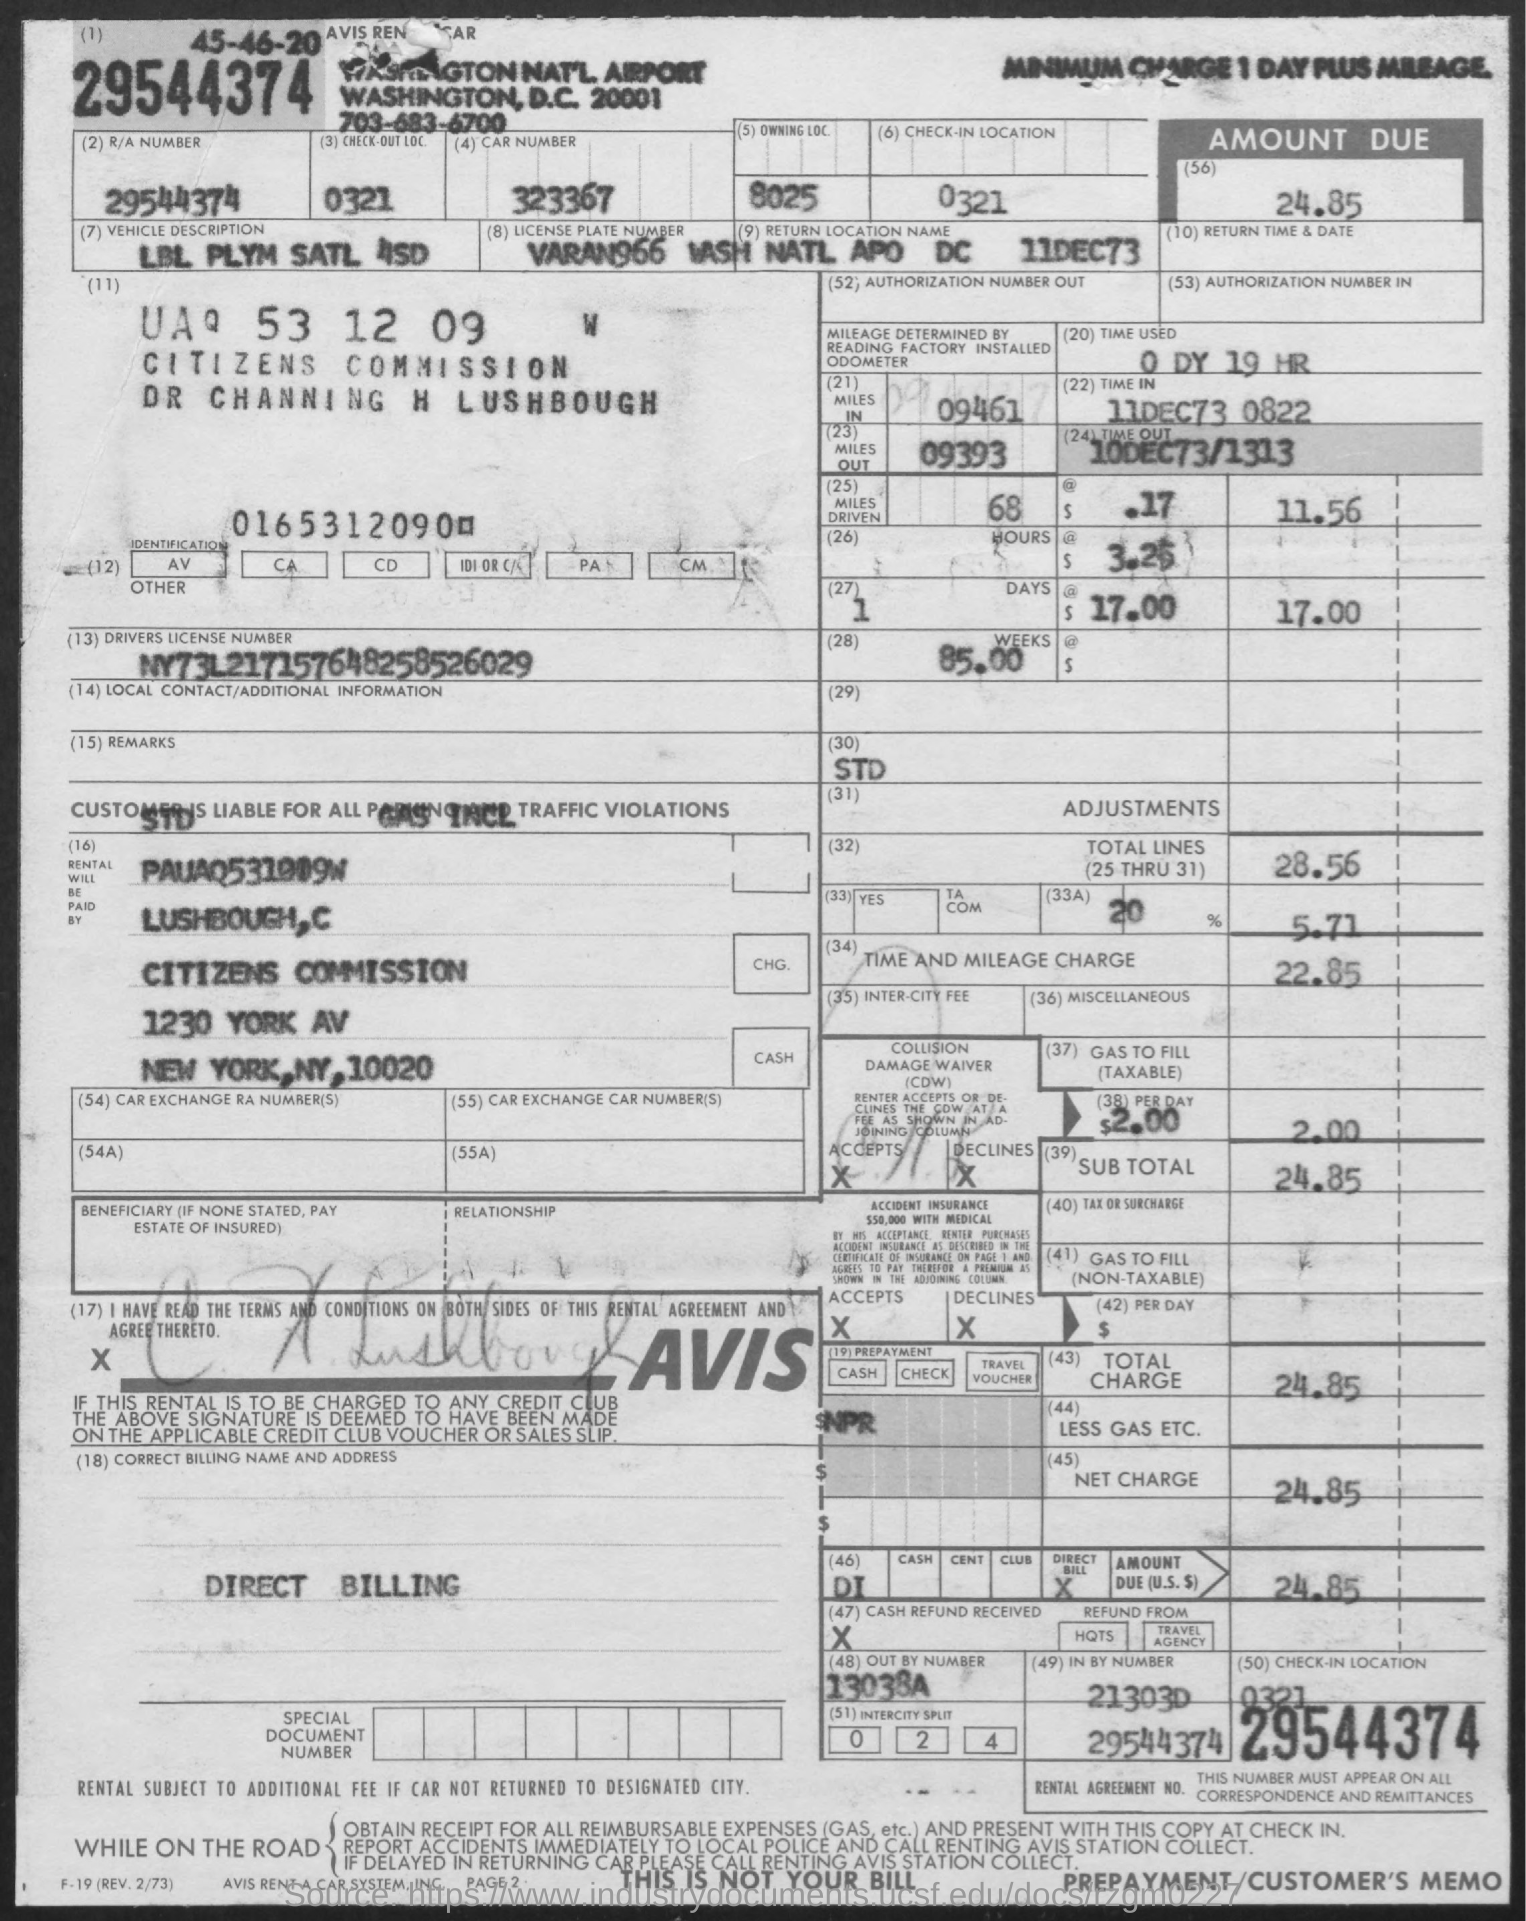What is the R/A Number of the car?
Your answer should be compact. 29544374. What is the car number given?
Your answer should be compact. 323367. What is the vehicle description mentioned in the document?
Your response must be concise. LBL PLYM SATL 4SD. What is the amount due mentioned in the document?
Provide a succinct answer. 24.85. What is the driver's license number given in the document?
Your answer should be very brief. NY73L217157648258526029. How much is the time and mileage charge given?
Offer a terse response. 22.85. 